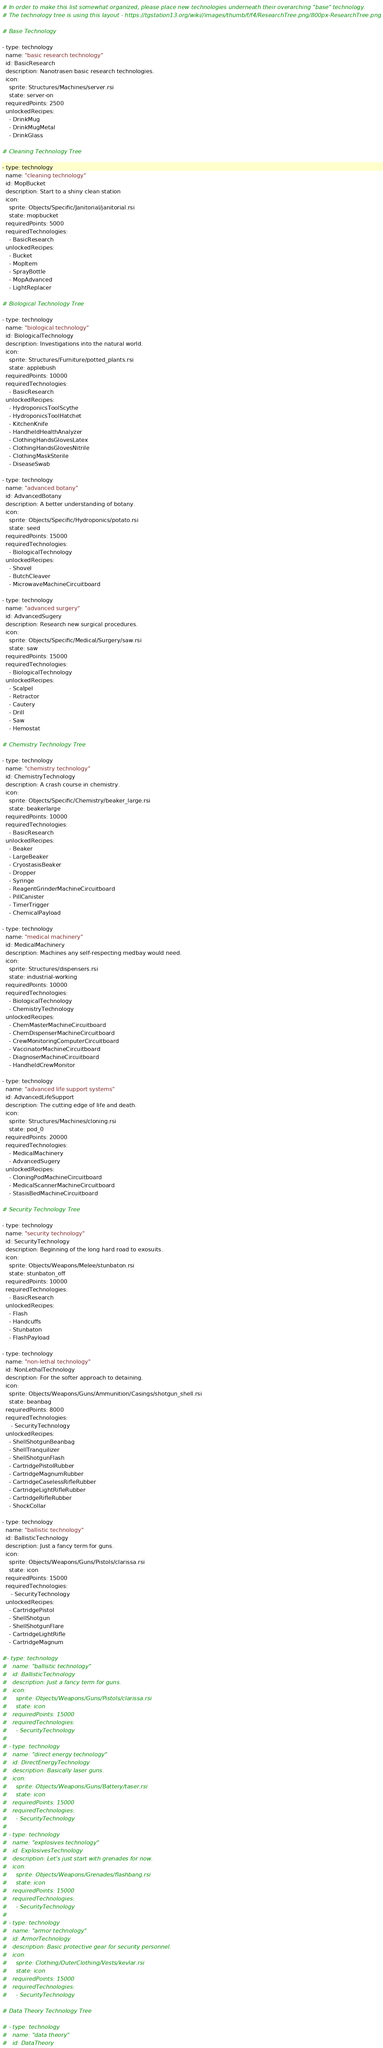<code> <loc_0><loc_0><loc_500><loc_500><_YAML_># In order to make this list somewhat organized, please place new technologies underneath their overarching "base" technology.
# The technology tree is using this layout - https://tgstation13.org/wiki//images/thumb/f/f4/ResearchTree.png/800px-ResearchTree.png

# Base Technology

- type: technology
  name: "basic research technology"
  id: BasicResearch
  description: Nanotrasen basic research technologies.
  icon:
    sprite: Structures/Machines/server.rsi
    state: server-on
  requiredPoints: 2500
  unlockedRecipes:
    - DrinkMug
    - DrinkMugMetal
    - DrinkGlass

# Cleaning Technology Tree

- type: technology
  name: "cleaning technology"
  id: MopBucket
  description: Start to a shiny clean station
  icon:
    sprite: Objects/Specific/Janitorial/janitorial.rsi
    state: mopbucket
  requiredPoints: 5000
  requiredTechnologies:
    - BasicResearch
  unlockedRecipes:
    - Bucket
    - MopItem
    - SprayBottle
    - MopAdvanced
    - LightReplacer

# Biological Technology Tree

- type: technology
  name: "biological technology"
  id: BiologicalTechnology
  description: Investigations into the natural world.
  icon:
    sprite: Structures/Furniture/potted_plants.rsi
    state: applebush
  requiredPoints: 10000
  requiredTechnologies:
    - BasicResearch
  unlockedRecipes:
    - HydroponicsToolScythe
    - HydroponicsToolHatchet
    - KitchenKnife
    - HandheldHealthAnalyzer
    - ClothingHandsGlovesLatex
    - ClothingHandsGlovesNitrile
    - ClothingMaskSterile
    - DiseaseSwab

- type: technology
  name: "advanced botany"
  id: AdvancedBotany
  description: A better understanding of botany.
  icon:
    sprite: Objects/Specific/Hydroponics/potato.rsi
    state: seed
  requiredPoints: 15000
  requiredTechnologies:
    - BiologicalTechnology
  unlockedRecipes:
    - Shovel
    - ButchCleaver
    - MicrowaveMachineCircuitboard

- type: technology
  name: "advanced surgery"
  id: AdvancedSugery
  description: Research new surgical procedures.
  icon:
    sprite: Objects/Specific/Medical/Surgery/saw.rsi
    state: saw
  requiredPoints: 15000
  requiredTechnologies:
    - BiologicalTechnology
  unlockedRecipes:
    - Scalpel
    - Retractor
    - Cautery
    - Drill
    - Saw
    - Hemostat

# Chemistry Technology Tree

- type: technology
  name: "chemistry technology"
  id: ChemistryTechnology
  description: A crash course in chemistry.
  icon:
    sprite: Objects/Specific/Chemistry/beaker_large.rsi
    state: beakerlarge
  requiredPoints: 10000
  requiredTechnologies:
    - BasicResearch
  unlockedRecipes:
    - Beaker
    - LargeBeaker
    - CryostasisBeaker
    - Dropper
    - Syringe
    - ReagentGrinderMachineCircuitboard
    - PillCanister
    - TimerTrigger
    - ChemicalPayload

- type: technology
  name: "medical machinery"
  id: MedicalMachinery
  description: Machines any self-respecting medbay would need.
  icon:
    sprite: Structures/dispensers.rsi
    state: industrial-working
  requiredPoints: 10000
  requiredTechnologies:
    - BiologicalTechnology
    - ChemistryTechnology
  unlockedRecipes:
    - ChemMasterMachineCircuitboard
    - ChemDispenserMachineCircuitboard
    - CrewMonitoringComputerCircuitboard
    - VaccinatorMachineCircuitboard
    - DiagnoserMachineCircuitboard
    - HandheldCrewMonitor

- type: technology
  name: "advanced life support systems"
  id: AdvancedLifeSupport
  description: The cutting edge of life and death.
  icon:
    sprite: Structures/Machines/cloning.rsi
    state: pod_0
  requiredPoints: 20000
  requiredTechnologies:
    - MedicalMachinery
    - AdvancedSugery
  unlockedRecipes:
    - CloningPodMachineCircuitboard
    - MedicalScannerMachineCircuitboard
    - StasisBedMachineCircuitboard

# Security Technology Tree

- type: technology
  name: "security technology"
  id: SecurityTechnology
  description: Beginning of the long hard road to exosuits.
  icon:
    sprite: Objects/Weapons/Melee/stunbaton.rsi
    state: stunbaton_off
  requiredPoints: 10000
  requiredTechnologies:
    - BasicResearch
  unlockedRecipes:
    - Flash
    - Handcuffs
    - Stunbaton
    - FlashPayload

- type: technology
  name: "non-lethal technology"
  id: NonLethalTechnology
  description: For the softer approach to detaining.
  icon:
    sprite: Objects/Weapons/Guns/Ammunition/Casings/shotgun_shell.rsi
    state: beanbag
  requiredPoints: 8000
  requiredTechnologies:
     - SecurityTechnology
  unlockedRecipes:
    - ShellShotgunBeanbag
    - ShellTranquilizer
    - ShellShotgunFlash
    - CartridgePistolRubber
    - CartridgeMagnumRubber
    - CartridgeCaselessRifleRubber
    - CartridgeLightRifleRubber
    - CartridgeRifleRubber
    - ShockCollar

- type: technology
  name: "ballistic technology"
  id: BallisticTechnology
  description: Just a fancy term for guns.
  icon:
    sprite: Objects/Weapons/Guns/Pistols/clarissa.rsi
    state: icon
  requiredPoints: 15000
  requiredTechnologies:
     - SecurityTechnology
  unlockedRecipes:
    - CartridgePistol
    - ShellShotgun
    - ShellShotgunFlare
    - CartridgeLightRifle
    - CartridgeMagnum

#- type: technology
#   name: "ballistic technology"
#   id: BallisticTechnology
#   description: Just a fancy term for guns.
#   icon:
#     sprite: Objects/Weapons/Guns/Pistols/clarissa.rsi
#     state: icon
#   requiredPoints: 15000
#   requiredTechnologies:
#     - SecurityTechnology
#
# - type: technology
#   name: "direct energy technology"
#   id: DirectEnergyTechnology
#   description: Basically laser guns.
#   icon:
#     sprite: Objects/Weapons/Guns/Battery/taser.rsi
#     state: icon
#   requiredPoints: 15000
#   requiredTechnologies:
#     - SecurityTechnology
#
# - type: technology
#   name: "explosives technology"
#   id: ExplosivesTechnology
#   description: Let's just start with grenades for now.
#   icon:
#     sprite: Objects/Weapons/Grenades/flashbang.rsi
#     state: icon
#   requiredPoints: 15000
#   requiredTechnologies:
#     - SecurityTechnology
#
# - type: technology
#   name: "armor technology"
#   id: ArmorTechnology
#   description: Basic protective gear for security personnel.
#   icon:
#     sprite: Clothing/OuterClothing/Vests/kevlar.rsi
#     state: icon
#   requiredPoints: 15000
#   requiredTechnologies:
#     - SecurityTechnology

# Data Theory Technology Tree

# - type: technology
#   name: "data theory"
#   id: DataTheory</code> 